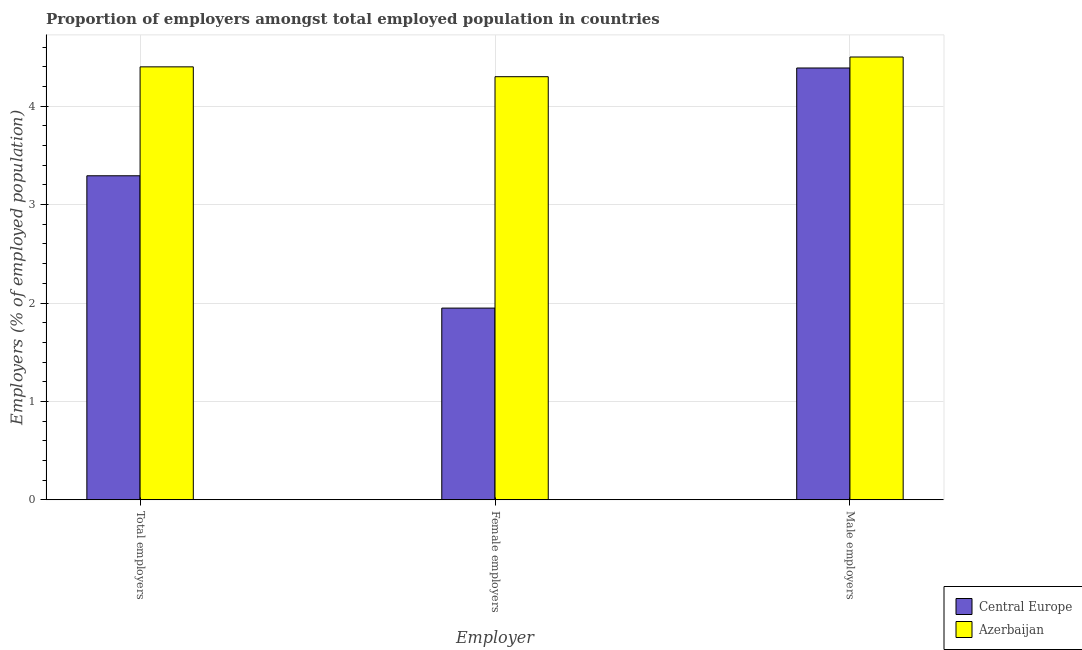How many different coloured bars are there?
Provide a succinct answer. 2. Are the number of bars per tick equal to the number of legend labels?
Your answer should be very brief. Yes. Are the number of bars on each tick of the X-axis equal?
Ensure brevity in your answer.  Yes. What is the label of the 2nd group of bars from the left?
Offer a very short reply. Female employers. What is the percentage of female employers in Central Europe?
Your response must be concise. 1.95. Across all countries, what is the minimum percentage of total employers?
Offer a very short reply. 3.29. In which country was the percentage of male employers maximum?
Offer a very short reply. Azerbaijan. In which country was the percentage of male employers minimum?
Offer a terse response. Central Europe. What is the total percentage of total employers in the graph?
Your answer should be very brief. 7.69. What is the difference between the percentage of female employers in Azerbaijan and that in Central Europe?
Offer a terse response. 2.35. What is the difference between the percentage of total employers in Central Europe and the percentage of male employers in Azerbaijan?
Your response must be concise. -1.21. What is the average percentage of male employers per country?
Provide a short and direct response. 4.44. What is the difference between the percentage of female employers and percentage of male employers in Central Europe?
Your answer should be compact. -2.44. In how many countries, is the percentage of male employers greater than 0.4 %?
Give a very brief answer. 2. What is the ratio of the percentage of female employers in Central Europe to that in Azerbaijan?
Provide a short and direct response. 0.45. Is the difference between the percentage of total employers in Azerbaijan and Central Europe greater than the difference between the percentage of female employers in Azerbaijan and Central Europe?
Your answer should be very brief. No. What is the difference between the highest and the second highest percentage of male employers?
Your response must be concise. 0.11. What is the difference between the highest and the lowest percentage of male employers?
Keep it short and to the point. 0.11. Is the sum of the percentage of total employers in Azerbaijan and Central Europe greater than the maximum percentage of male employers across all countries?
Your answer should be compact. Yes. What does the 1st bar from the left in Male employers represents?
Make the answer very short. Central Europe. What does the 2nd bar from the right in Female employers represents?
Provide a short and direct response. Central Europe. How many bars are there?
Your answer should be very brief. 6. How many countries are there in the graph?
Your answer should be compact. 2. Does the graph contain any zero values?
Make the answer very short. No. How many legend labels are there?
Your response must be concise. 2. What is the title of the graph?
Offer a terse response. Proportion of employers amongst total employed population in countries. What is the label or title of the X-axis?
Your answer should be compact. Employer. What is the label or title of the Y-axis?
Ensure brevity in your answer.  Employers (% of employed population). What is the Employers (% of employed population) in Central Europe in Total employers?
Provide a succinct answer. 3.29. What is the Employers (% of employed population) of Azerbaijan in Total employers?
Your response must be concise. 4.4. What is the Employers (% of employed population) in Central Europe in Female employers?
Offer a terse response. 1.95. What is the Employers (% of employed population) in Azerbaijan in Female employers?
Give a very brief answer. 4.3. What is the Employers (% of employed population) of Central Europe in Male employers?
Offer a very short reply. 4.39. What is the Employers (% of employed population) in Azerbaijan in Male employers?
Give a very brief answer. 4.5. Across all Employer, what is the maximum Employers (% of employed population) of Central Europe?
Your answer should be very brief. 4.39. Across all Employer, what is the maximum Employers (% of employed population) in Azerbaijan?
Offer a very short reply. 4.5. Across all Employer, what is the minimum Employers (% of employed population) in Central Europe?
Ensure brevity in your answer.  1.95. Across all Employer, what is the minimum Employers (% of employed population) in Azerbaijan?
Your answer should be compact. 4.3. What is the total Employers (% of employed population) of Central Europe in the graph?
Your response must be concise. 9.63. What is the total Employers (% of employed population) of Azerbaijan in the graph?
Provide a succinct answer. 13.2. What is the difference between the Employers (% of employed population) of Central Europe in Total employers and that in Female employers?
Your response must be concise. 1.34. What is the difference between the Employers (% of employed population) of Azerbaijan in Total employers and that in Female employers?
Keep it short and to the point. 0.1. What is the difference between the Employers (% of employed population) in Central Europe in Total employers and that in Male employers?
Provide a succinct answer. -1.1. What is the difference between the Employers (% of employed population) in Azerbaijan in Total employers and that in Male employers?
Your answer should be very brief. -0.1. What is the difference between the Employers (% of employed population) in Central Europe in Female employers and that in Male employers?
Keep it short and to the point. -2.44. What is the difference between the Employers (% of employed population) of Central Europe in Total employers and the Employers (% of employed population) of Azerbaijan in Female employers?
Keep it short and to the point. -1.01. What is the difference between the Employers (% of employed population) of Central Europe in Total employers and the Employers (% of employed population) of Azerbaijan in Male employers?
Ensure brevity in your answer.  -1.21. What is the difference between the Employers (% of employed population) of Central Europe in Female employers and the Employers (% of employed population) of Azerbaijan in Male employers?
Provide a short and direct response. -2.55. What is the average Employers (% of employed population) of Central Europe per Employer?
Provide a succinct answer. 3.21. What is the average Employers (% of employed population) in Azerbaijan per Employer?
Your answer should be very brief. 4.4. What is the difference between the Employers (% of employed population) in Central Europe and Employers (% of employed population) in Azerbaijan in Total employers?
Ensure brevity in your answer.  -1.11. What is the difference between the Employers (% of employed population) of Central Europe and Employers (% of employed population) of Azerbaijan in Female employers?
Keep it short and to the point. -2.35. What is the difference between the Employers (% of employed population) of Central Europe and Employers (% of employed population) of Azerbaijan in Male employers?
Your answer should be compact. -0.11. What is the ratio of the Employers (% of employed population) of Central Europe in Total employers to that in Female employers?
Keep it short and to the point. 1.69. What is the ratio of the Employers (% of employed population) in Azerbaijan in Total employers to that in Female employers?
Your answer should be compact. 1.02. What is the ratio of the Employers (% of employed population) in Central Europe in Total employers to that in Male employers?
Keep it short and to the point. 0.75. What is the ratio of the Employers (% of employed population) of Azerbaijan in Total employers to that in Male employers?
Ensure brevity in your answer.  0.98. What is the ratio of the Employers (% of employed population) in Central Europe in Female employers to that in Male employers?
Provide a short and direct response. 0.44. What is the ratio of the Employers (% of employed population) of Azerbaijan in Female employers to that in Male employers?
Offer a very short reply. 0.96. What is the difference between the highest and the second highest Employers (% of employed population) in Central Europe?
Your answer should be very brief. 1.1. What is the difference between the highest and the second highest Employers (% of employed population) of Azerbaijan?
Offer a very short reply. 0.1. What is the difference between the highest and the lowest Employers (% of employed population) in Central Europe?
Your response must be concise. 2.44. 